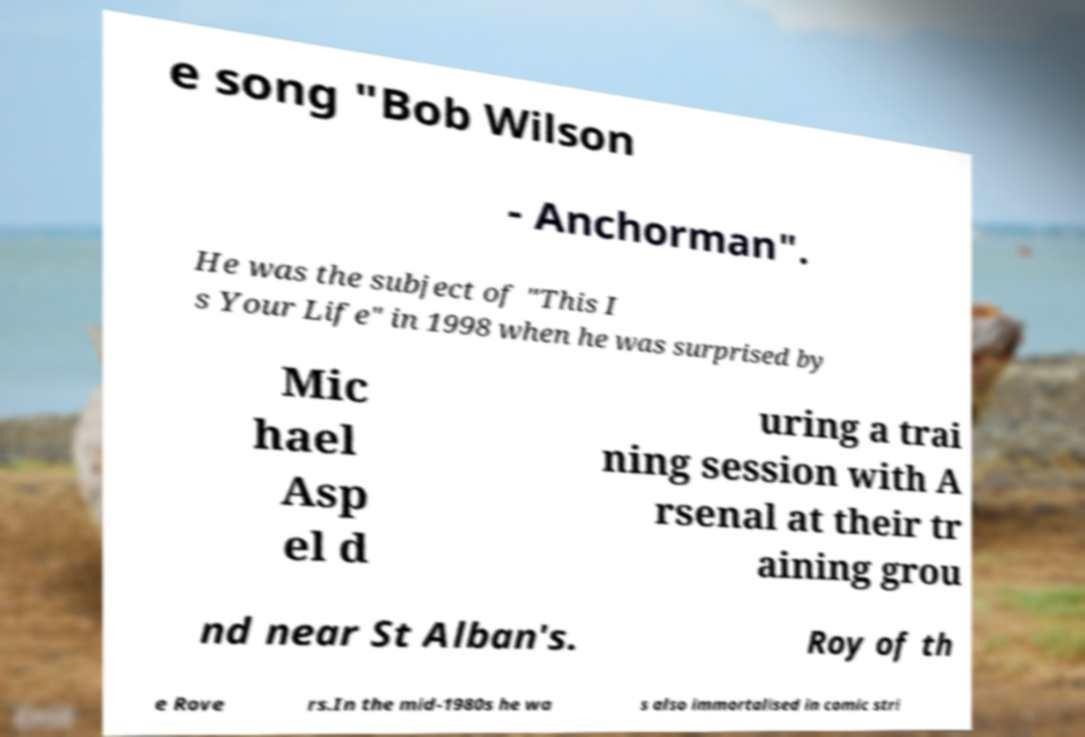Could you extract and type out the text from this image? e song "Bob Wilson - Anchorman". He was the subject of "This I s Your Life" in 1998 when he was surprised by Mic hael Asp el d uring a trai ning session with A rsenal at their tr aining grou nd near St Alban's. Roy of th e Rove rs.In the mid-1980s he wa s also immortalised in comic stri 